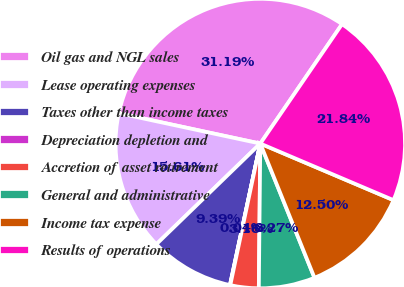Convert chart to OTSL. <chart><loc_0><loc_0><loc_500><loc_500><pie_chart><fcel>Oil gas and NGL sales<fcel>Lease operating expenses<fcel>Taxes other than income taxes<fcel>Depreciation depletion and<fcel>Accretion of asset retirement<fcel>General and administrative<fcel>Income tax expense<fcel>Results of operations<nl><fcel>31.19%<fcel>15.61%<fcel>9.39%<fcel>0.04%<fcel>3.16%<fcel>6.27%<fcel>12.5%<fcel>21.84%<nl></chart> 